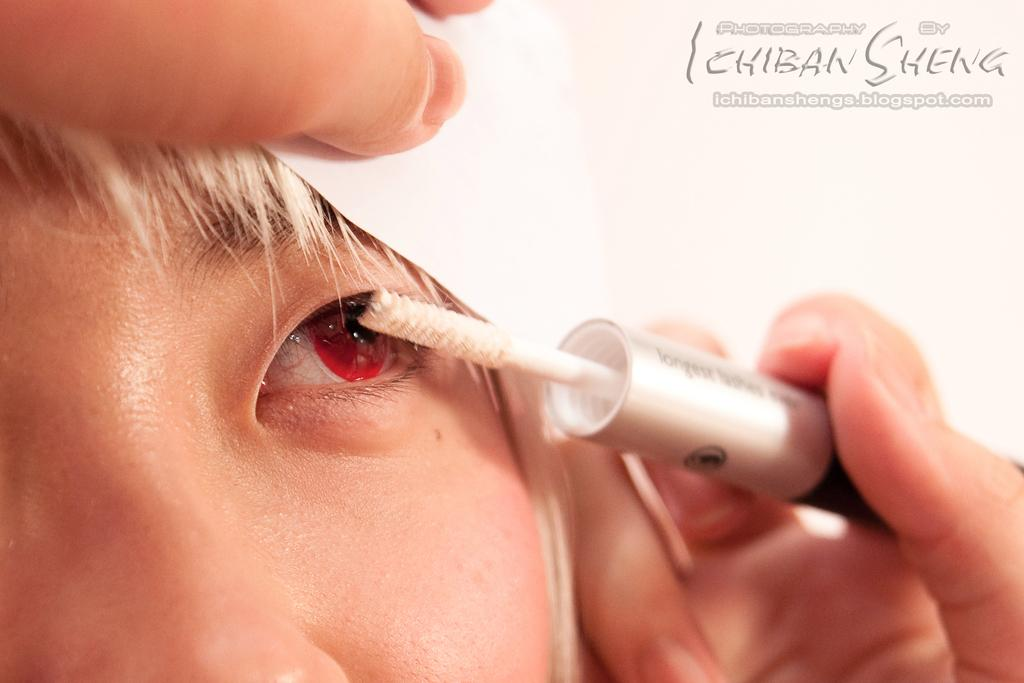What is the person in the image doing? The person is holding a paper in the image. Can you describe the object in the image? Unfortunately, the provided facts do not give any information about the object in the image. Is there any additional detail about the paper the person is holding? No additional detail about the paper is mentioned in the provided facts. What is the watermark on the image? The watermark on the image is not mentioned in the provided facts. How does the person in the image breathe while holding the paper? The person's breathing is not visible in the image, and there is no information about their breathing in the provided facts. 